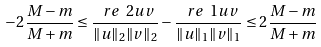Convert formula to latex. <formula><loc_0><loc_0><loc_500><loc_500>- 2 \frac { M - m } { M + m } \leq \frac { \ r e \ 2 u v } { \| u \| _ { 2 } \| v \| _ { 2 } } - \frac { \ r e \ 1 u v } { \| u \| _ { 1 } \| v \| _ { 1 } } \leq 2 \frac { M - m } { M + m }</formula> 